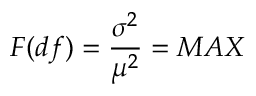Convert formula to latex. <formula><loc_0><loc_0><loc_500><loc_500>F ( d f ) = \frac { \sigma ^ { 2 } } { \mu ^ { 2 } } = M A X</formula> 